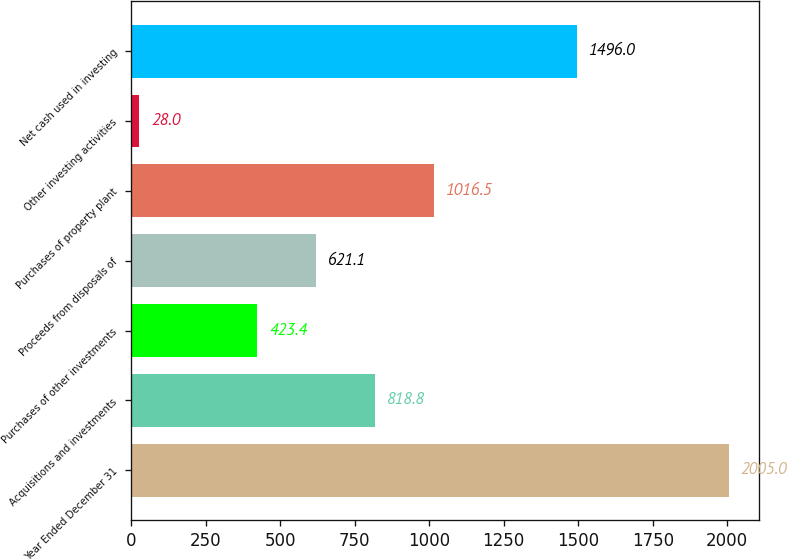Convert chart. <chart><loc_0><loc_0><loc_500><loc_500><bar_chart><fcel>Year Ended December 31<fcel>Acquisitions and investments<fcel>Purchases of other investments<fcel>Proceeds from disposals of<fcel>Purchases of property plant<fcel>Other investing activities<fcel>Net cash used in investing<nl><fcel>2005<fcel>818.8<fcel>423.4<fcel>621.1<fcel>1016.5<fcel>28<fcel>1496<nl></chart> 